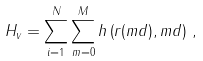Convert formula to latex. <formula><loc_0><loc_0><loc_500><loc_500>H _ { v } = \sum _ { i = 1 } ^ { N } \sum _ { m = 0 } ^ { M } h \left ( { r } ( m d ) , m d \right ) \, ,</formula> 